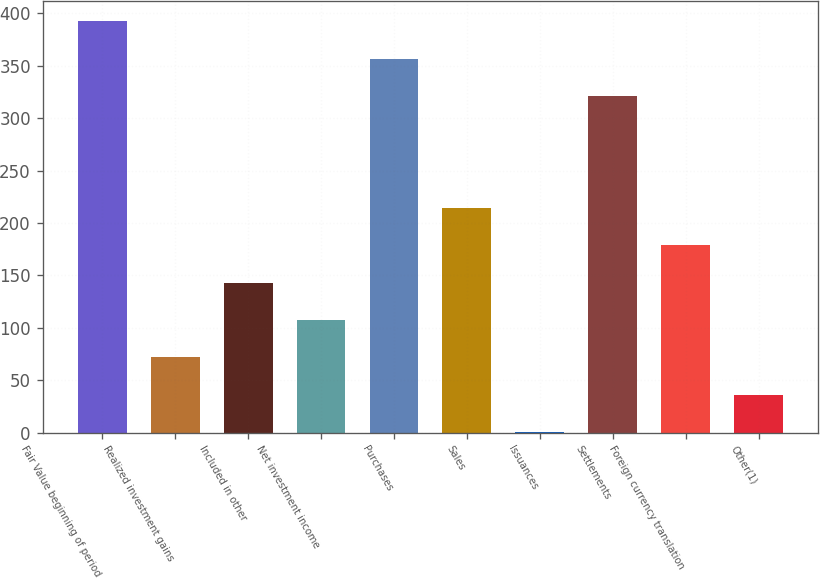Convert chart to OTSL. <chart><loc_0><loc_0><loc_500><loc_500><bar_chart><fcel>Fair Value beginning of period<fcel>Realized investment gains<fcel>Included in other<fcel>Net investment income<fcel>Purchases<fcel>Sales<fcel>Issuances<fcel>Settlements<fcel>Foreign currency translation<fcel>Other(1)<nl><fcel>392.65<fcel>71.8<fcel>143.1<fcel>107.45<fcel>357<fcel>214.4<fcel>0.5<fcel>321.35<fcel>178.75<fcel>36.15<nl></chart> 